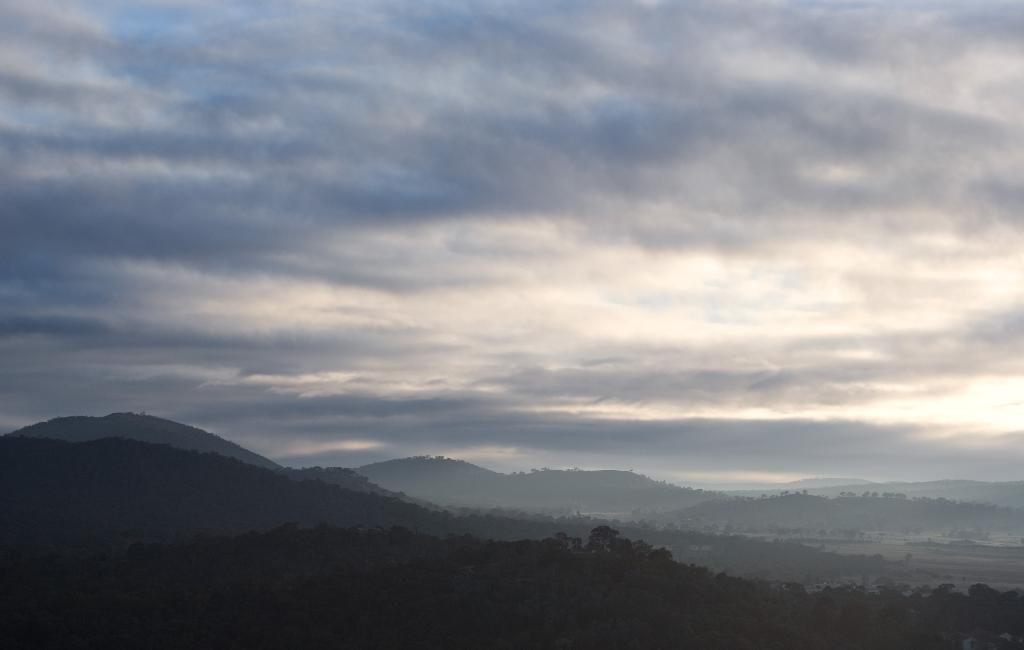What type of natural elements can be seen in the image? There are plants and mountains in the image. What part of the natural environment is visible in the image? The sky is visible in the image. What type of metal can be seen in the image? There is no metal present in the image; it features plants, mountains, and the sky. What letters are visible on the coach in the image? There is no coach present in the image, so there are no letters visible on a coach. 